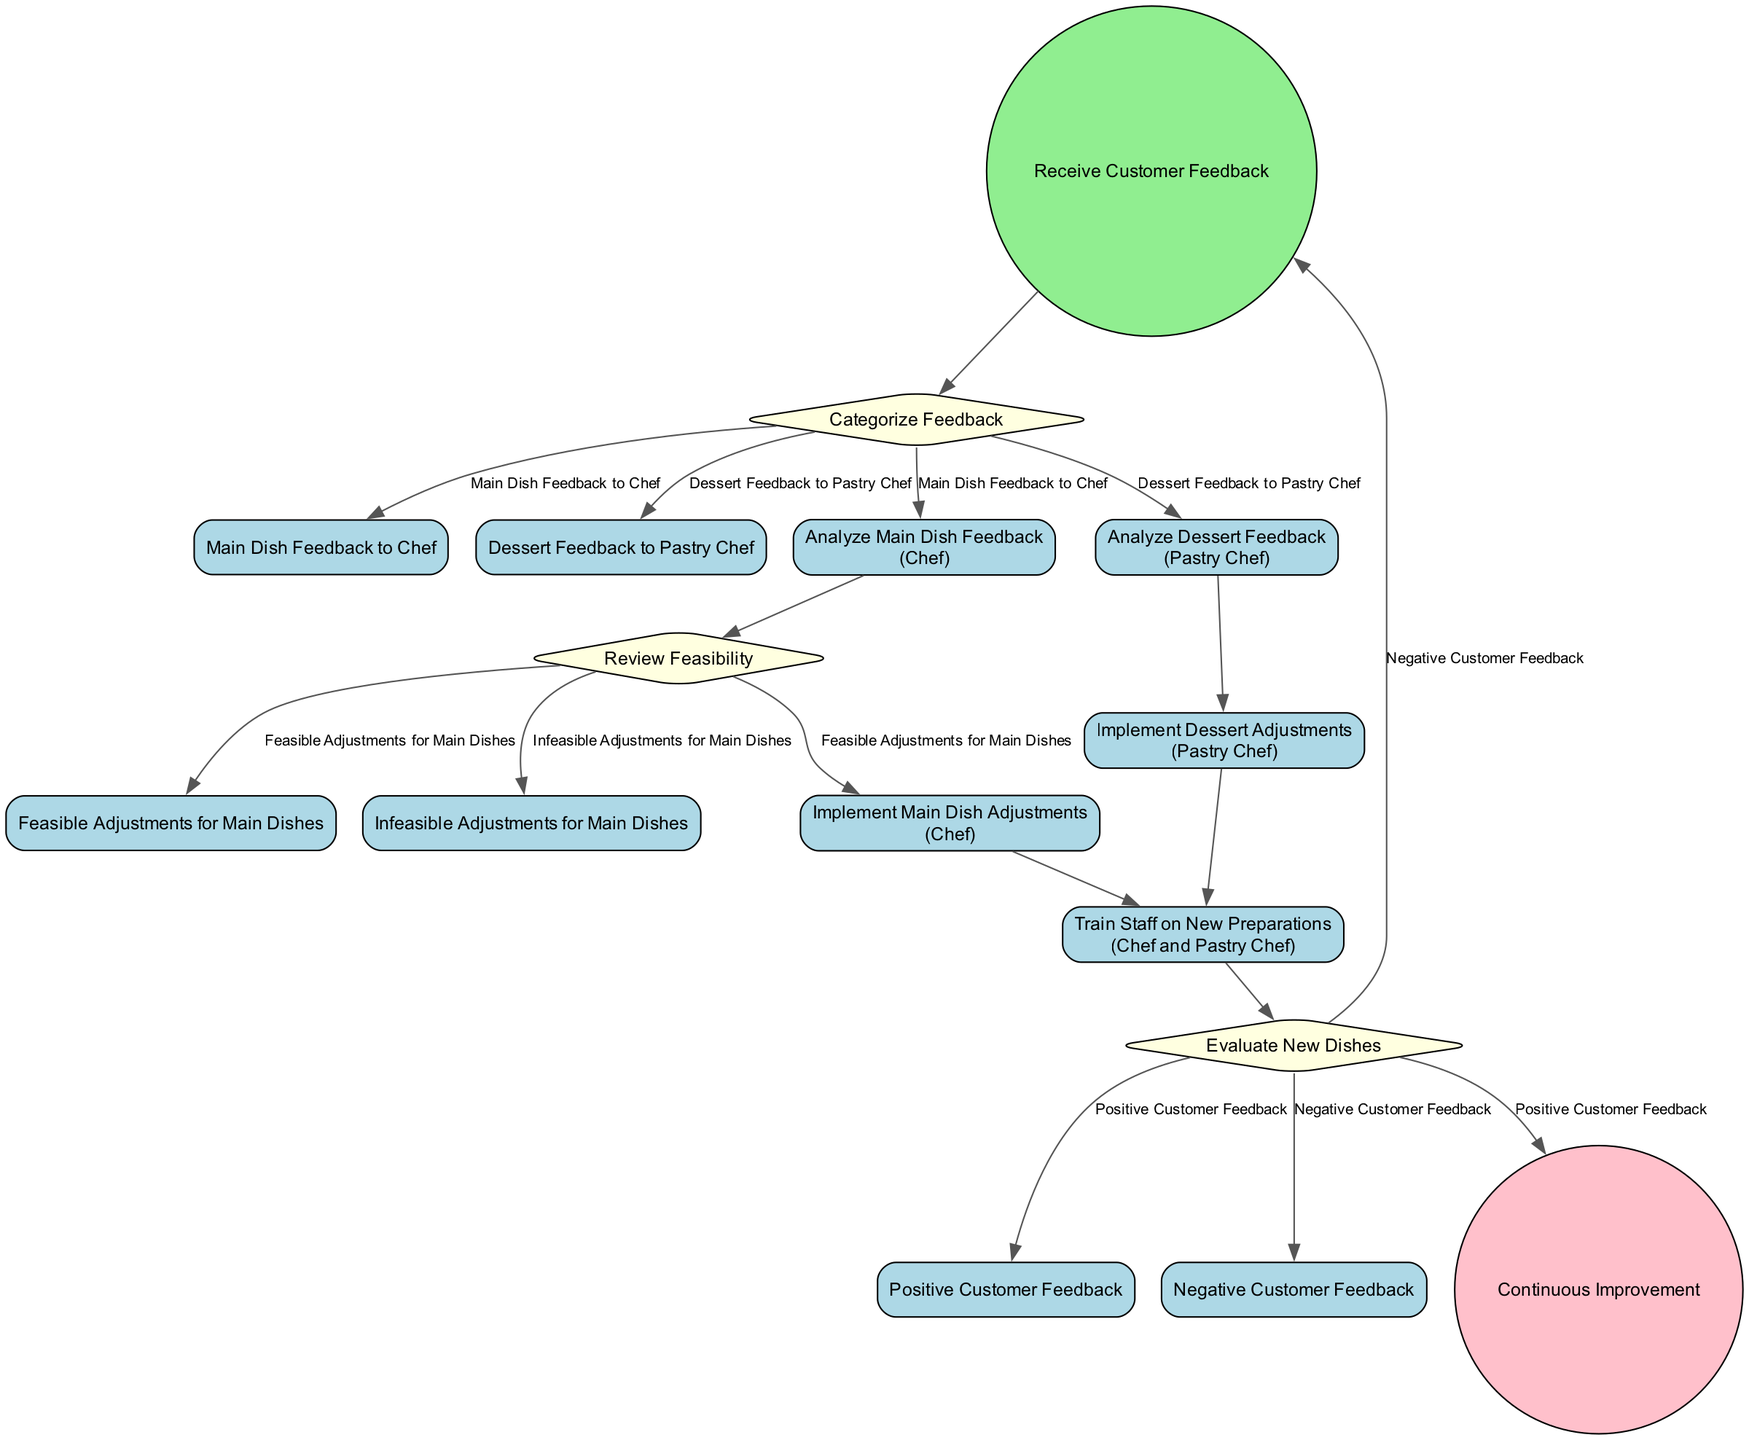What initiates the process in the diagram? The process begins with the node labeled "Receive Customer Feedback," which is depicted as the starting point in the flow.
Answer: Receive Customer Feedback How many decision nodes are in the diagram? The diagram contains three decision nodes: "Categorize Feedback," "Review Feasibility," and "Evaluate New Dishes." Counting these gives a total of three.
Answer: 3 What happens after analyzing main dish feedback? After analyzing main dish feedback at the "Analyze Main Dish Feedback" step, the next action is to "Review Feasibility," indicating a step toward determining possible adjustments.
Answer: Review Feasibility What are the two conditions for evaluating new dishes? The evaluation of new dishes focuses on two conditions: "Positive Customer Feedback" and "Negative Customer Feedback." These determine the next steps in the process.
Answer: Positive Customer Feedback and Negative Customer Feedback Which actor is involved in training staff on new preparations? The training of staff on new preparations is conducted by both the Chef and Pastry Chef, as specified in the node labeled "Train Staff on New Preparations."
Answer: Chef and Pastry Chef What is the end result of the diagram? The final outcome of this activity diagram is labeled as "Continuous Improvement," which signifies the overall goal of implementing feedback.
Answer: Continuous Improvement What happens when there is negative customer feedback? In the case of negative customer feedback, the diagram indicates a return to the "Receive Customer Feedback" node, showing that the process is iterative based on feedback quality.
Answer: Receive Customer Feedback What activity comes after implementing dessert adjustments? Following the "Implement Dessert Adjustments" activity, the next step is also to "Train Staff on New Preparations," which is a collaborative effort between the chefs.
Answer: Train Staff on New Preparations 